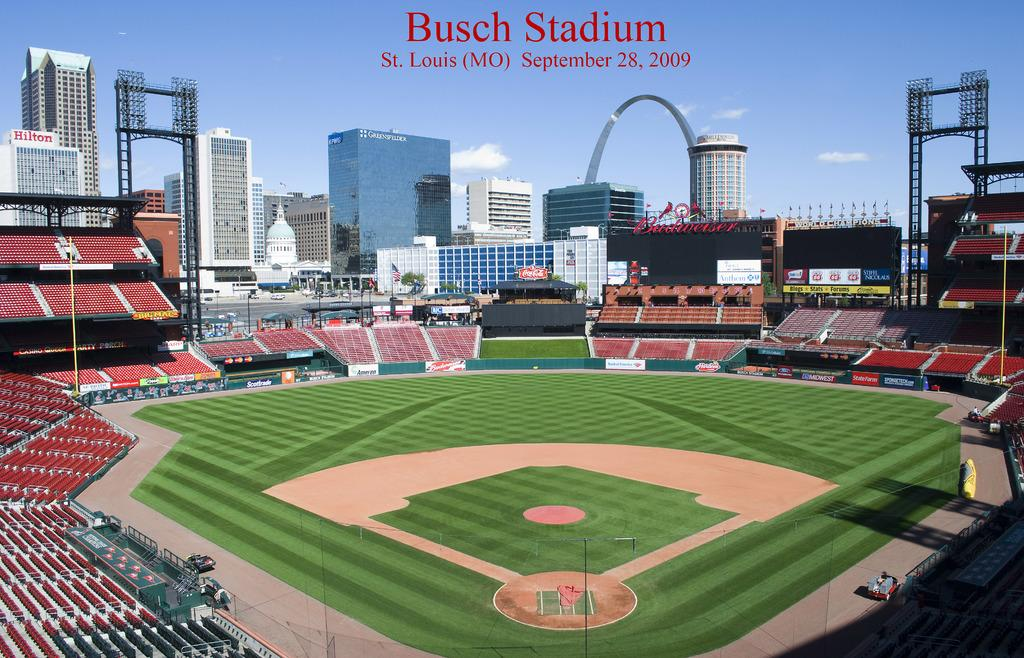<image>
Write a terse but informative summary of the picture. A promotional portrait of the Busch Baseball Stadium totally empty with the city skyline looming behind it. 